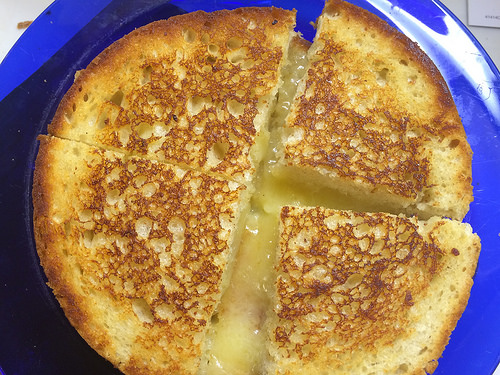<image>
Is the grilled cheese in the plate? No. The grilled cheese is not contained within the plate. These objects have a different spatial relationship. 